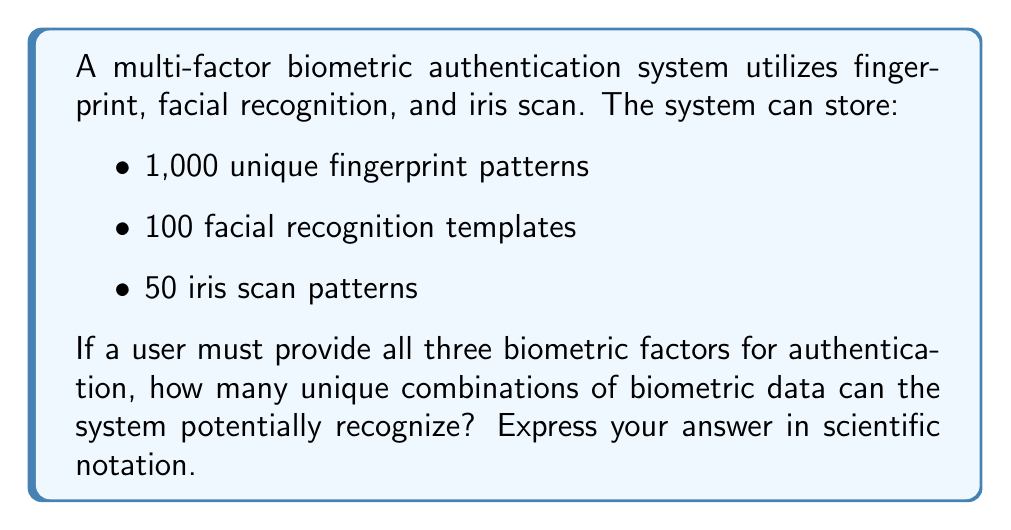Teach me how to tackle this problem. To solve this problem, we need to apply the multiplication principle of counting, which is closely related to exponents.

1) Each factor in the authentication system is independent of the others. This means we multiply the number of possibilities for each factor:

   $$ \text{Total combinations} = \text{Fingerprint options} \times \text{Facial recognition options} \times \text{Iris scan options} $$

2) Substituting the given values:

   $$ \text{Total combinations} = 1,000 \times 100 \times 50 $$

3) Multiply these numbers:

   $$ 1,000 \times 100 = 100,000 $$
   $$ 100,000 \times 50 = 5,000,000 $$

4) To express this in scientific notation, we identify the coefficient and the power of 10:

   $$ 5,000,000 = 5 \times 10^6 $$

This result indicates that the system can potentially recognize 5 million unique combinations of biometric data, which is a substantial number that could have significant implications for privacy and data security in biometric systems.
Answer: $5 \times 10^6$ 